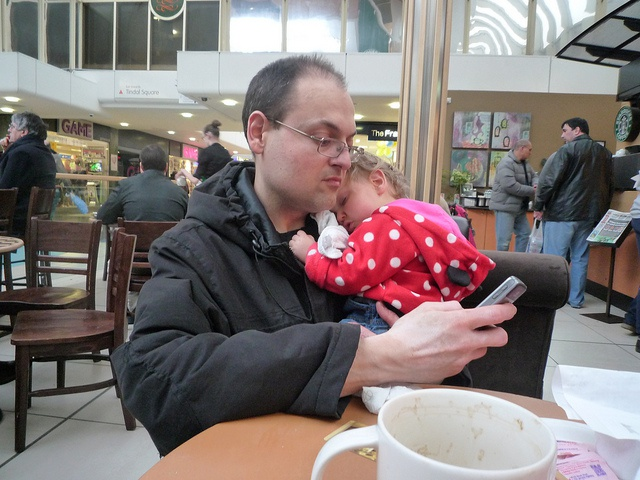Describe the objects in this image and their specific colors. I can see people in darkgray, black, and gray tones, people in darkgray, brown, and lightpink tones, cup in darkgray and lightgray tones, dining table in darkgray, tan, and black tones, and chair in darkgray, black, and gray tones in this image. 